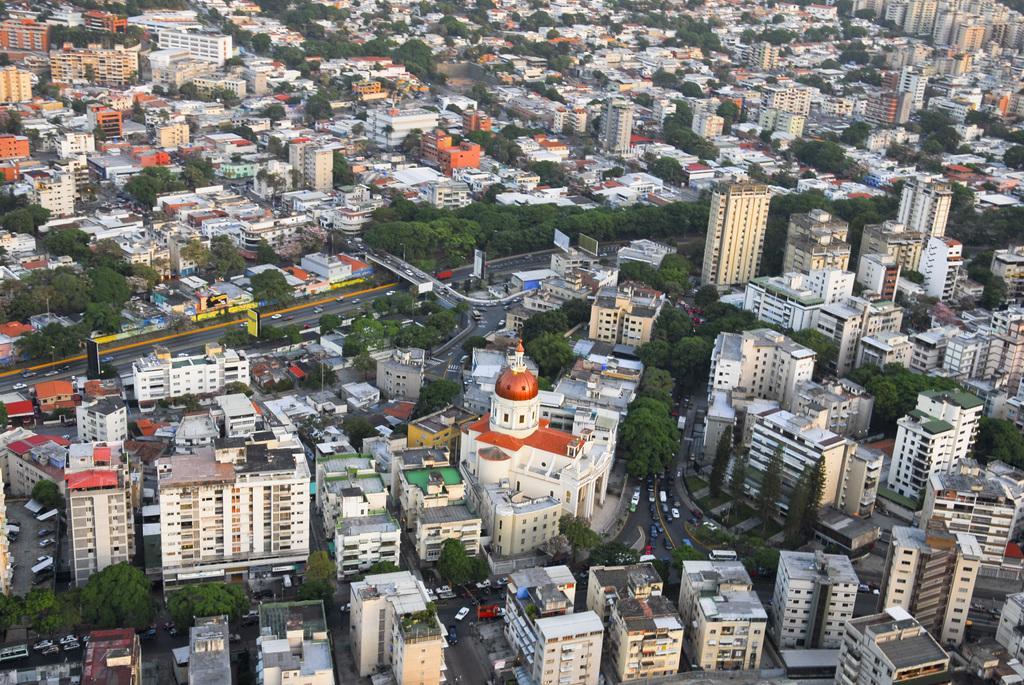Can you describe this image briefly? This is the overview of a city where we can see buildings, trees, roads and vehicles on road. 